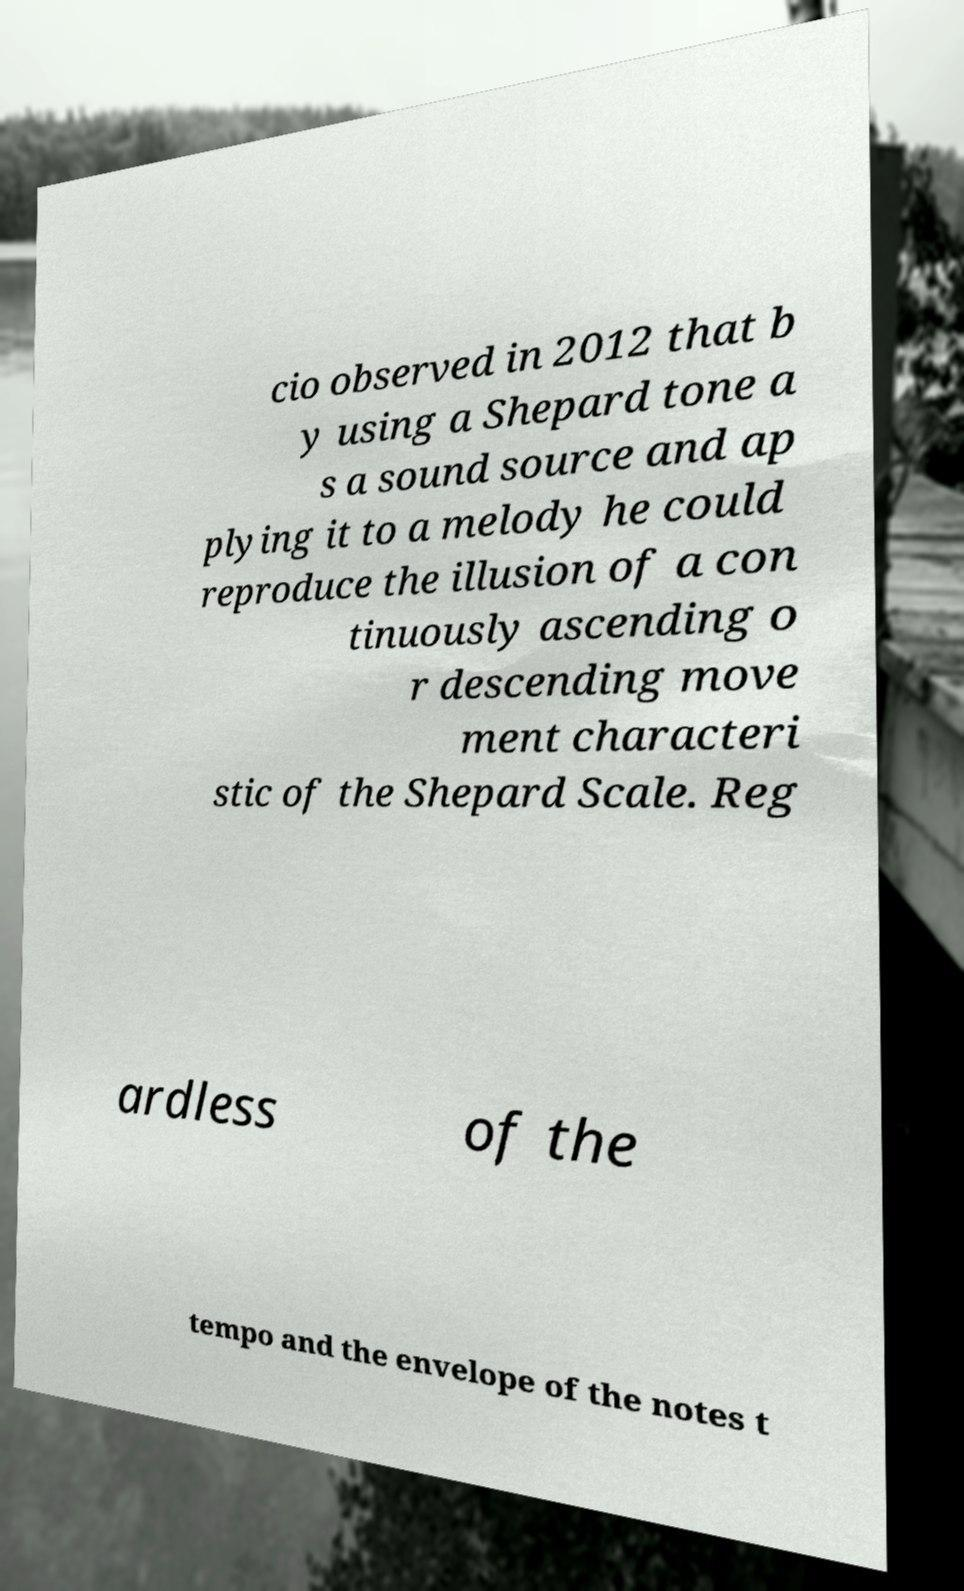I need the written content from this picture converted into text. Can you do that? cio observed in 2012 that b y using a Shepard tone a s a sound source and ap plying it to a melody he could reproduce the illusion of a con tinuously ascending o r descending move ment characteri stic of the Shepard Scale. Reg ardless of the tempo and the envelope of the notes t 